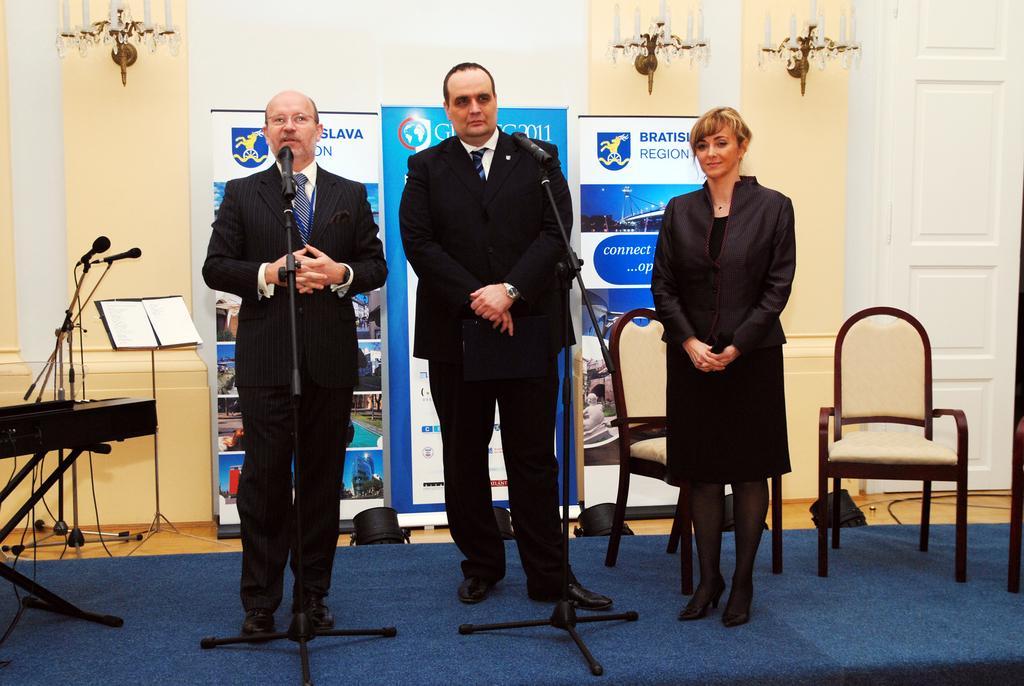Can you describe this image briefly? In the middle of the picture, we see three people standing. The man on the left side is talking on microphone. Beside him, we see a table on which microphone and book stand are placed. Behind them, we see boards with text written on it. Behind that, we see a white wall and yellow wall. On the right corner, we see white door. 